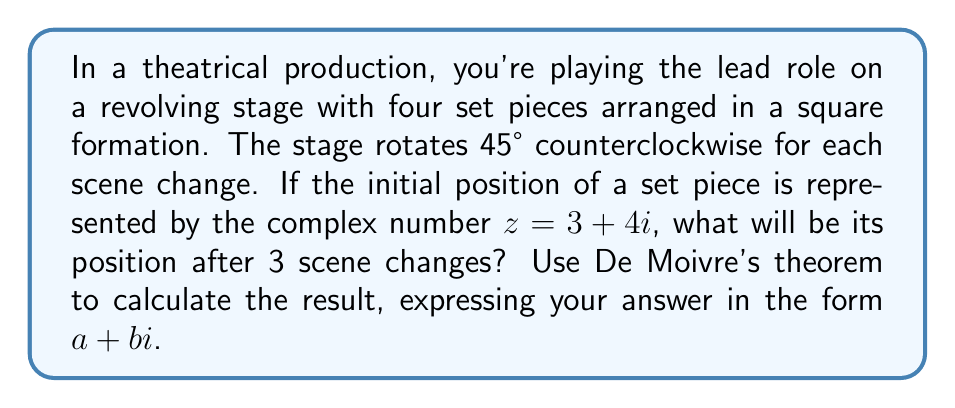Show me your answer to this math problem. To solve this problem, we'll use De Moivre's theorem, which states that for any complex number $z$ and any real number $n$:

$$(r(\cos\theta + i\sin\theta))^n = r^n(\cos(n\theta) + i\sin(n\theta))$$

Here's how we'll approach the solution:

1) First, we need to express the initial position $z = 3 + 4i$ in polar form:
   
   $r = \sqrt{3^2 + 4^2} = 5$
   $\theta = \arctan(\frac{4}{3}) \approx 0.9273$ radians

   So, $z = 5(\cos(0.9273) + i\sin(0.9273))$

2) Each rotation is 45° counterclockwise, which is $\frac{\pi}{4}$ radians. After 3 rotations, the total angle of rotation is $3 \cdot \frac{\pi}{4}$ radians.

3) We can represent this rotation as multiplication by $(\cos(\frac{3\pi}{4}) + i\sin(\frac{3\pi}{4}))$

4) Applying De Moivre's theorem:

   $z_{new} = 5(\cos(0.9273) + i\sin(0.9273)) \cdot (\cos(\frac{3\pi}{4}) + i\sin(\frac{3\pi}{4}))$

   $= 5(\cos(0.9273 + \frac{3\pi}{4}) + i\sin(0.9273 + \frac{3\pi}{4}))$

5) Now we need to convert this back to rectangular form:

   $z_{new} = 5\cos(0.9273 + \frac{3\pi}{4}) + 5i\sin(0.9273 + \frac{3\pi}{4})$

6) Calculating these values (you can use a calculator):

   $5\cos(0.9273 + \frac{3\pi}{4}) \approx -4.9619$
   $5\sin(0.9273 + \frac{3\pi}{4}) \approx 0.6142$

Therefore, the new position of the set piece after 3 scene changes is approximately $-4.9619 + 0.6142i$.
Answer: $-4.9619 + 0.6142i$ 